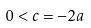Convert formula to latex. <formula><loc_0><loc_0><loc_500><loc_500>0 < c = - 2 a</formula> 